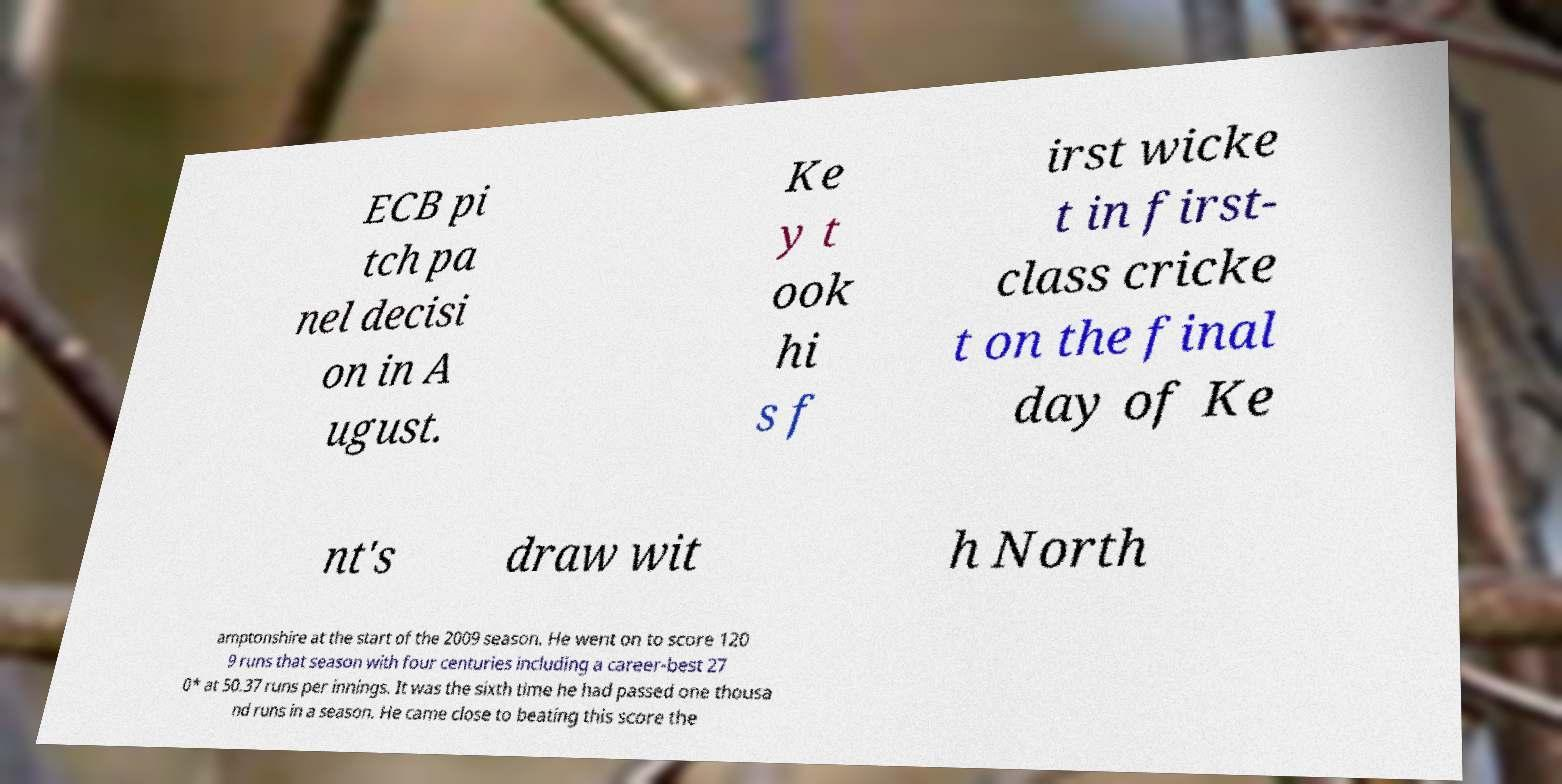What messages or text are displayed in this image? I need them in a readable, typed format. ECB pi tch pa nel decisi on in A ugust. Ke y t ook hi s f irst wicke t in first- class cricke t on the final day of Ke nt's draw wit h North amptonshire at the start of the 2009 season. He went on to score 120 9 runs that season with four centuries including a career-best 27 0* at 50.37 runs per innings. It was the sixth time he had passed one thousa nd runs in a season. He came close to beating this score the 